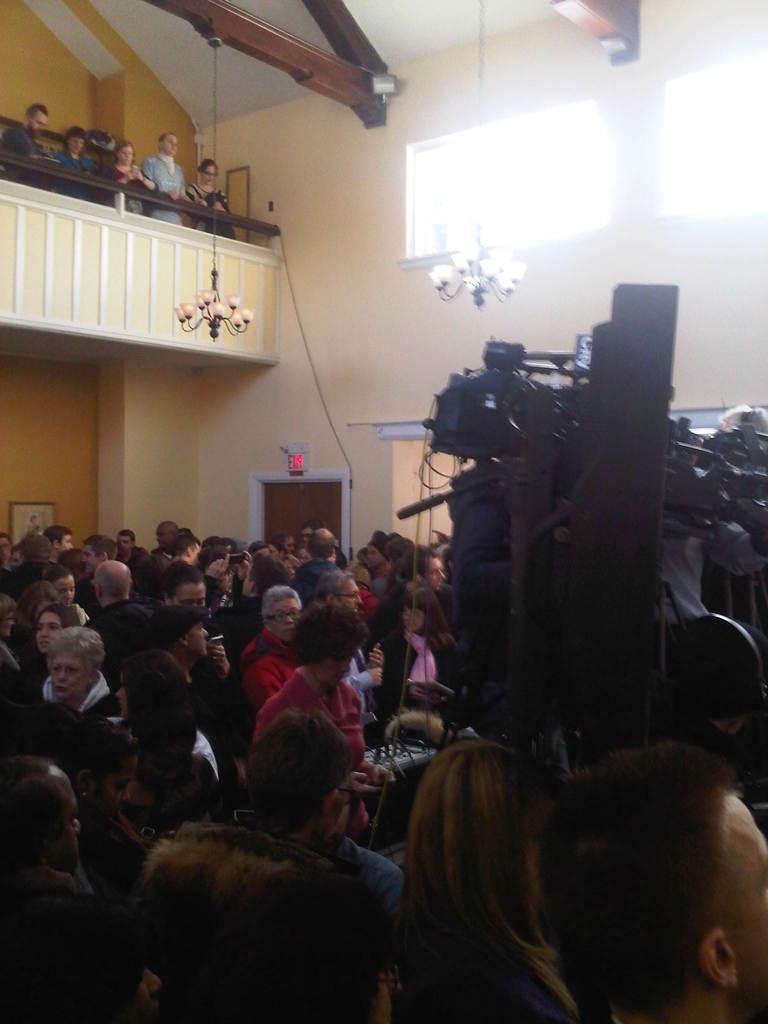Can you describe this image briefly? In this image, we can see a crowd inside the building. There is a camera on the right side of the image. There are some persons in the top left of the image standing on the balcony. There are chandeliers hanging from the ceiling. There are ventilators in the top right of the image. 